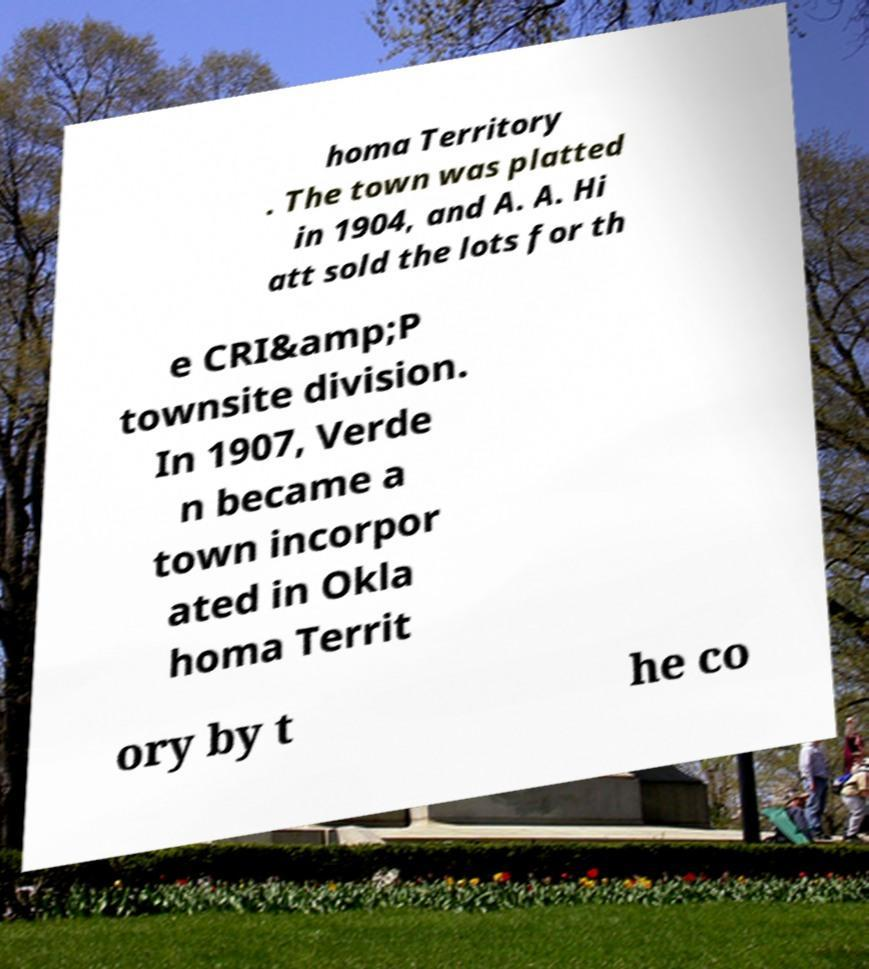Please read and relay the text visible in this image. What does it say? homa Territory . The town was platted in 1904, and A. A. Hi att sold the lots for th e CRI&amp;P townsite division. In 1907, Verde n became a town incorpor ated in Okla homa Territ ory by t he co 